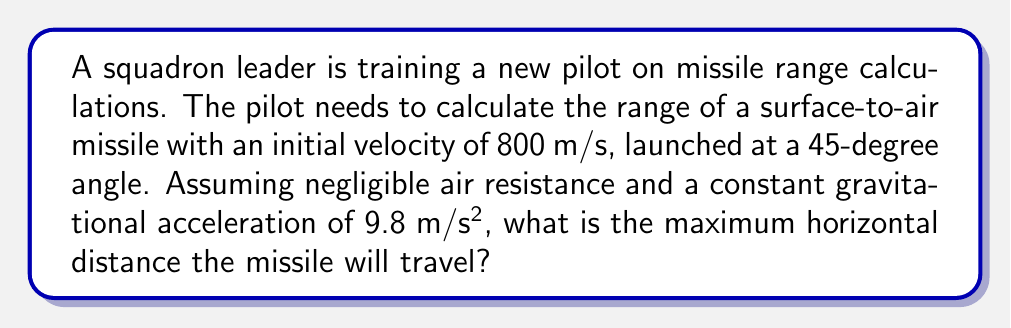Give your solution to this math problem. To solve this problem, we'll use the equations of motion for projectile motion. Let's break it down step-by-step:

1. Identify the known variables:
   - Initial velocity: $v_0 = 800$ m/s
   - Launch angle: $\theta = 45°$
   - Gravitational acceleration: $g = 9.8$ m/s²

2. For a projectile launched at an angle, the range (R) is given by the formula:

   $$R = \frac{v_0^2 \sin(2\theta)}{g}$$

3. Convert the angle to radians:
   $45° = \frac{\pi}{4}$ radians

4. Calculate $\sin(2\theta)$:
   $\sin(2\theta) = \sin(2 \cdot \frac{\pi}{4}) = \sin(\frac{\pi}{2}) = 1$

5. Substitute the values into the range equation:

   $$R = \frac{(800)^2 \cdot 1}{9.8}$$

6. Simplify:
   $$R = \frac{640,000}{9.8} = 65,306.12$$

7. Round to a reasonable number of significant figures:

   $$R \approx 65,300 \text{ meters}$$

This calculation assumes ideal conditions without air resistance. In reality, atmospheric conditions would significantly affect the missile's trajectory and range.
Answer: 65,300 meters 